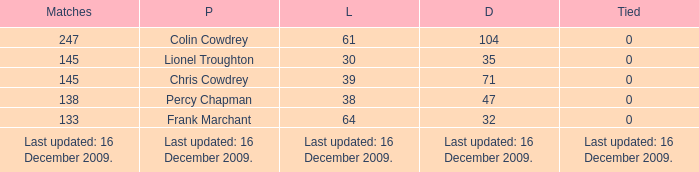I want to know the tie for drawn of 47 0.0. 